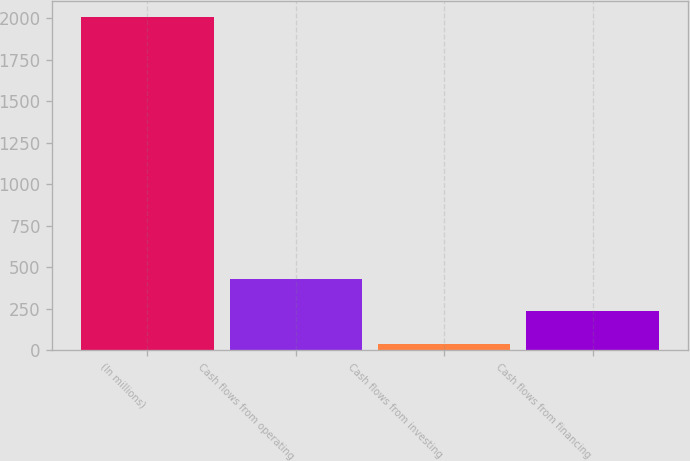<chart> <loc_0><loc_0><loc_500><loc_500><bar_chart><fcel>(In millions)<fcel>Cash flows from operating<fcel>Cash flows from investing<fcel>Cash flows from financing<nl><fcel>2006<fcel>430<fcel>36<fcel>233<nl></chart> 